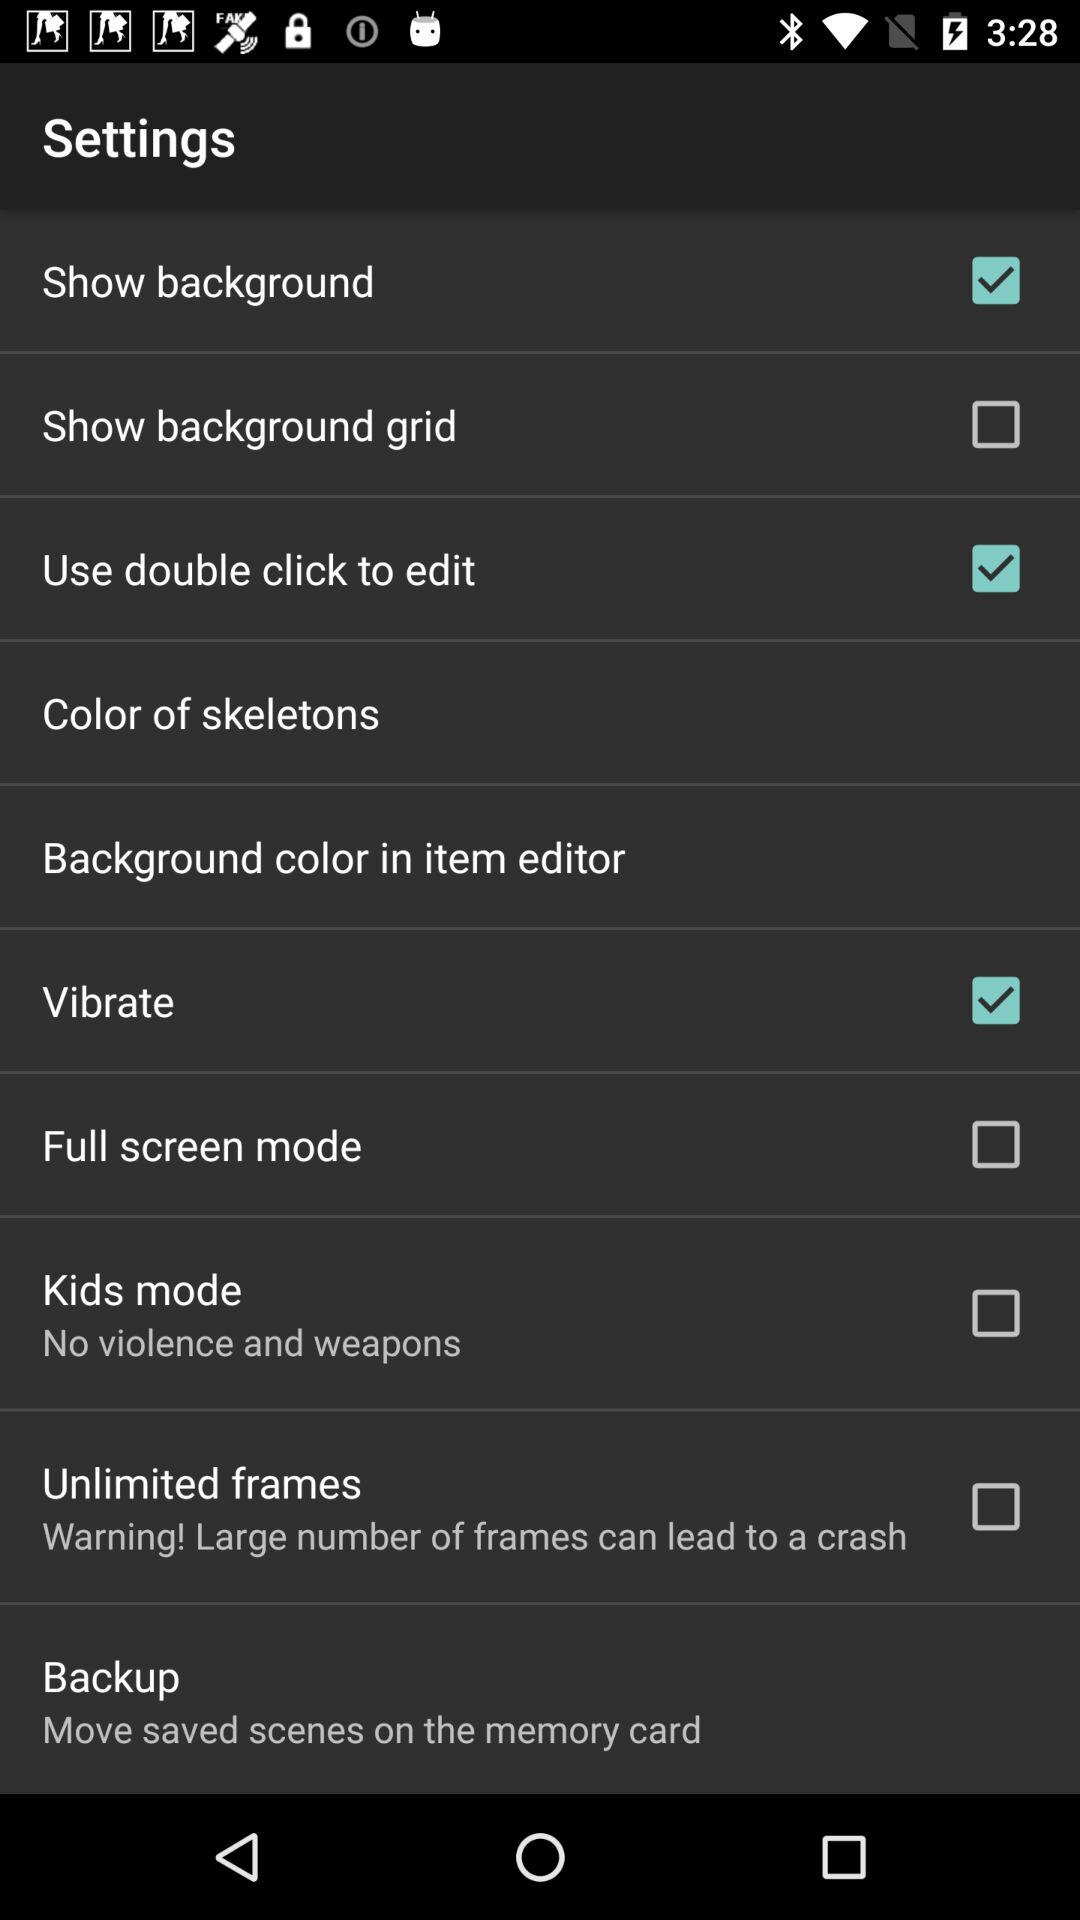For which functions are the settings on? The functions are "Show background", "Use double click to edit", and "Vibrate". 